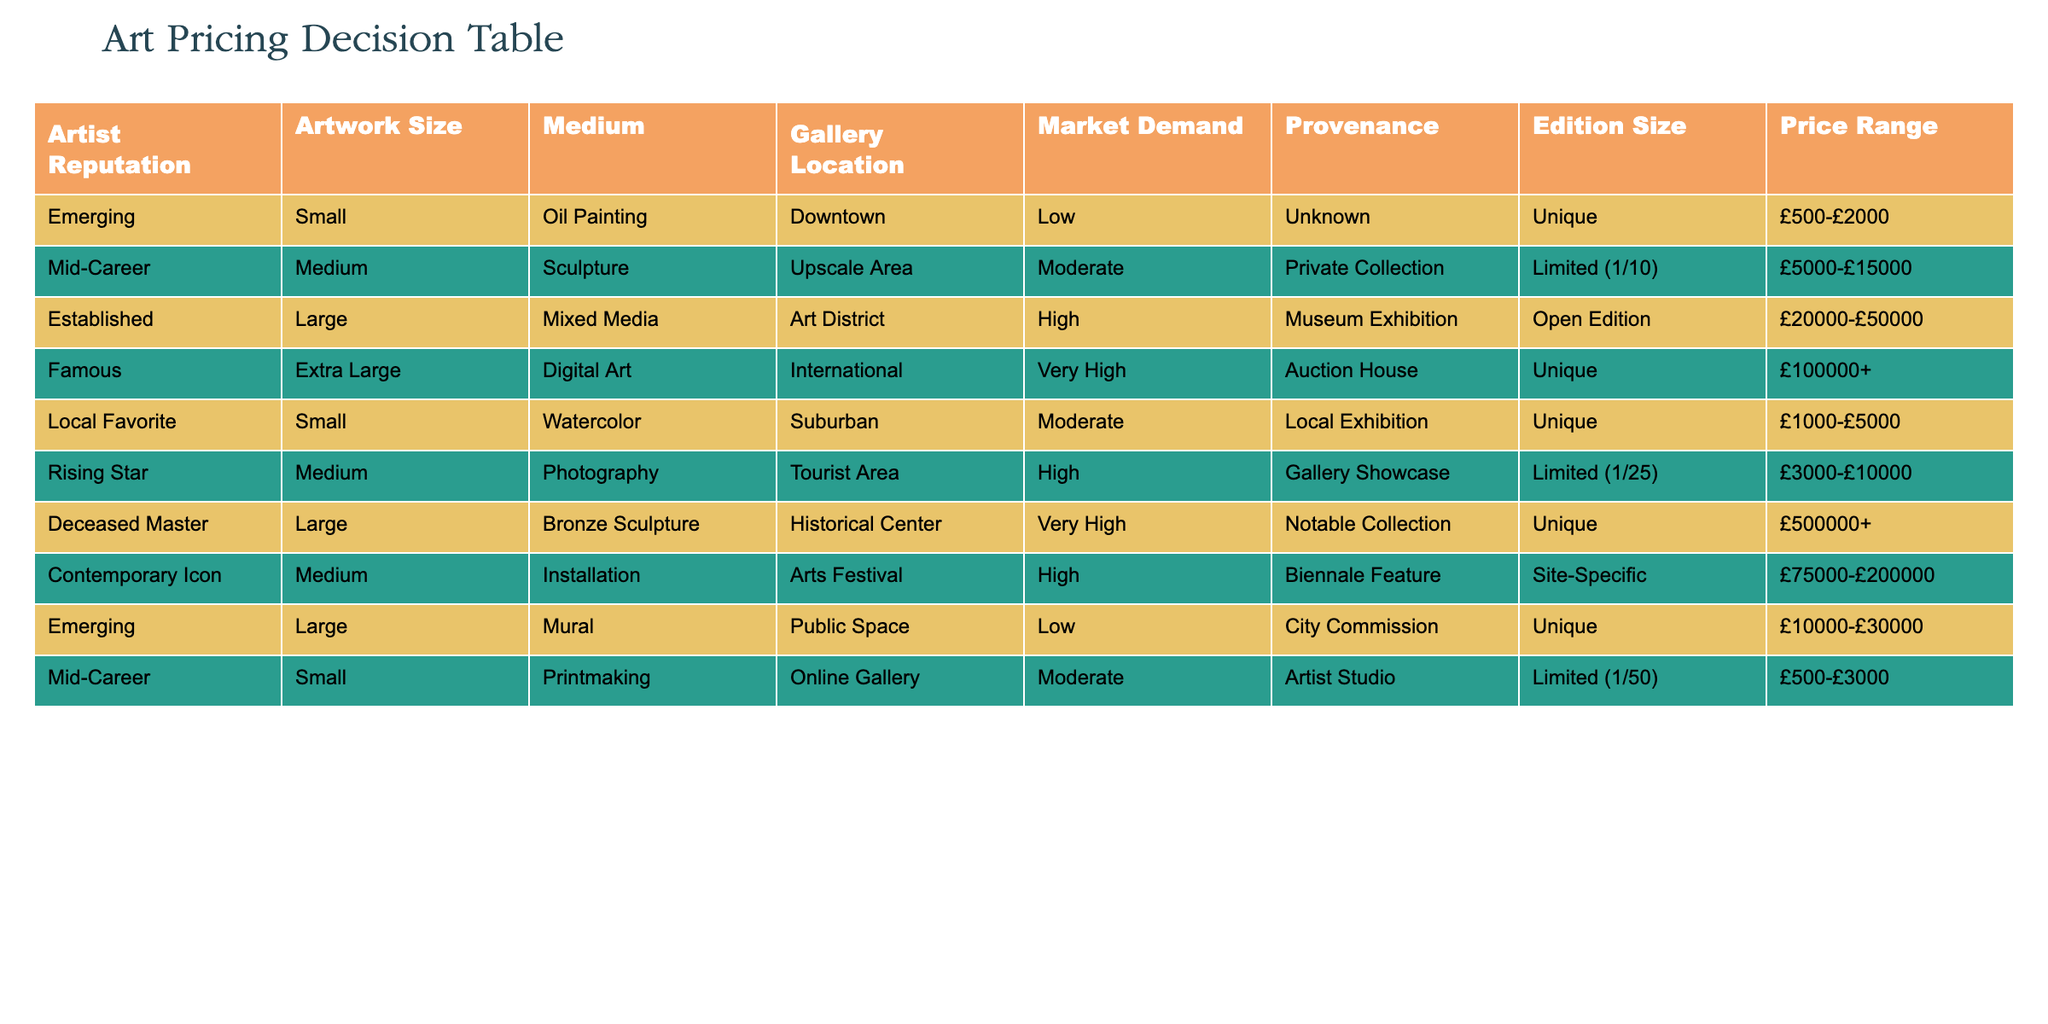What is the highest price range of artworks listed in the table? The highest price range is found in the row for Deceased Master which is £500000+.
Answer: £500000+ Which medium has the largest average price range? To find the largest average price, we sum the ranges of each medium and then divide by the number of entries for that medium. For bronze sculpture (Deceased Master), the range is £500000+; for installation (Contemporary Icon), it is £75000-£200000. Digital Art (Famous) starts at £100000+. Thus, bronze sculpture has the highest average as it has a minimum of £500000.
Answer: Bronze sculpture Is there an artwork with a unique provenance priced between £10000 and £30000? Yes, the Emerging artist's large mural is listed with a unique provenance and the price range of £10000-£30000.
Answer: Yes What is the difference in price range between established artists and emerging artists for large artworks? The price range for established artists is £20000-£50000 and for emerging artists is £10000-£30000. The difference, considering the maximum of established (£50000) and the minimum of emerging (£10000), is £40000.
Answer: £40000 Are any artworks listed in the table categorized under "Local Favorite" priced higher than £5000? No, the price range for Local Favorite, which is a small watercolor, is £1000-£5000. Thus, there are no artworks categorized as such priced higher than £5000.
Answer: No Which artist category has the lowest market demand and what is the price range? The Emerging artist has the lowest market demand with a price range of £500-£2000.
Answer: Emerging artist, £500-£2000 What is the total number of artworks priced above £30000 in the table? The artworks priced above £30000 include: Established (£20000-£50000), Famous (£100000+), Deceased Master (£500000+), and Contemporary Icon (£75000-£200000). Therefore, there are four artworks priced above £30000.
Answer: 4 Is there any artwork with a limited edition size of 1/50? Yes, the Mid-Career artist's small printmaking has a limited edition size of 1/50.
Answer: Yes What is the average price range of artworks in suburban locations? The only artwork listed in the suburban location is the Local Favorite (small watercolor) with a price range of £1000-£5000. Since there's only one price range, the average is the same as the only entry: (£1000-£5000).
Answer: £1000-£5000 